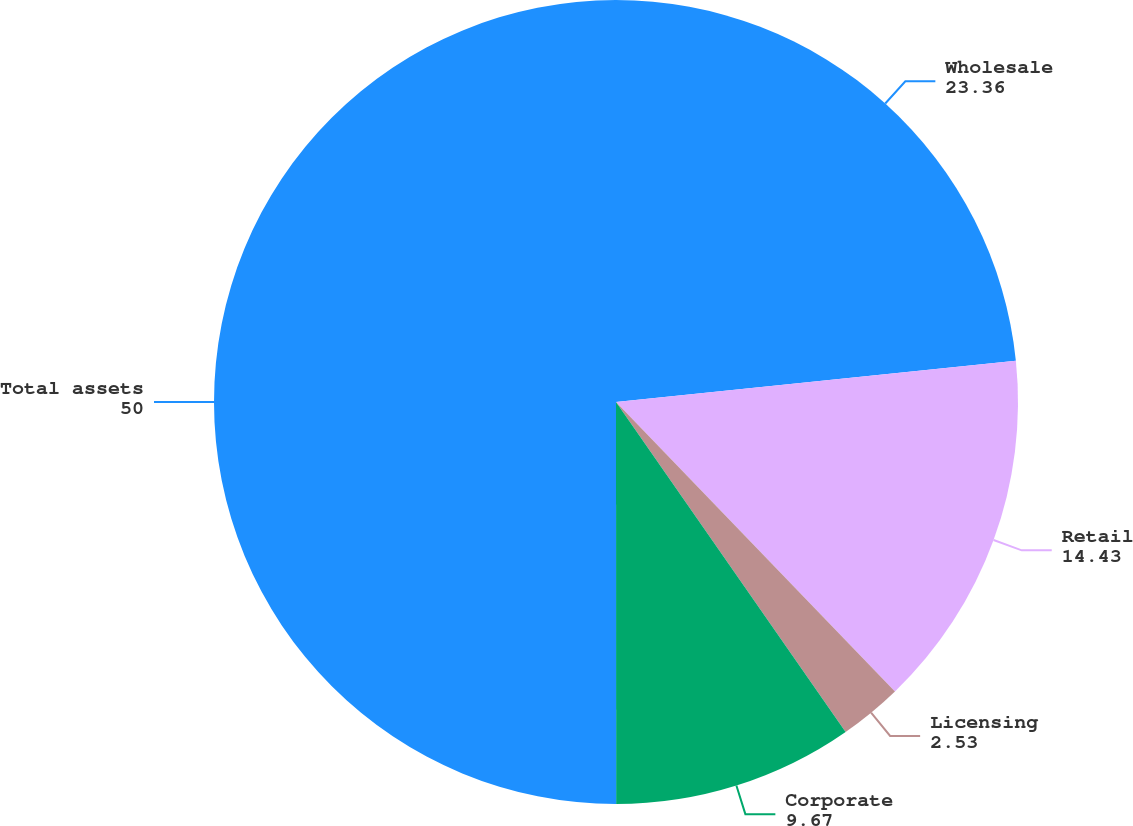Convert chart to OTSL. <chart><loc_0><loc_0><loc_500><loc_500><pie_chart><fcel>Wholesale<fcel>Retail<fcel>Licensing<fcel>Corporate<fcel>Total assets<nl><fcel>23.36%<fcel>14.43%<fcel>2.53%<fcel>9.67%<fcel>50.0%<nl></chart> 